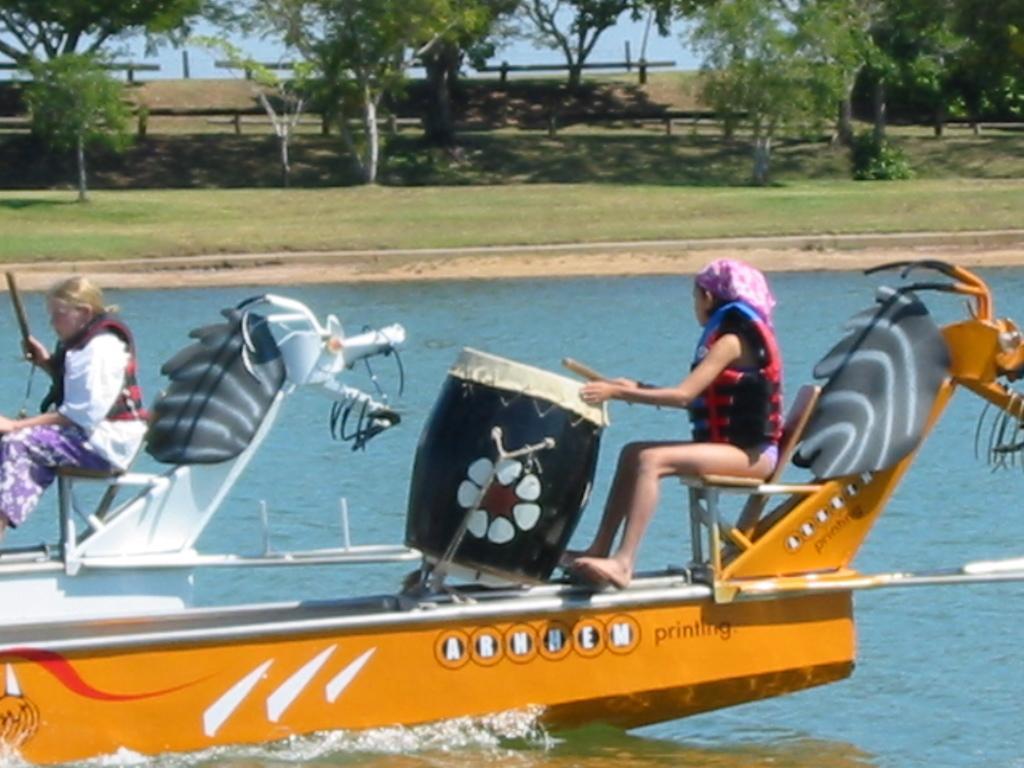Could you give a brief overview of what you see in this image? There are two persons on the boat and she is playing drums. This is water. In the background we can see plants, grass, and trees. 